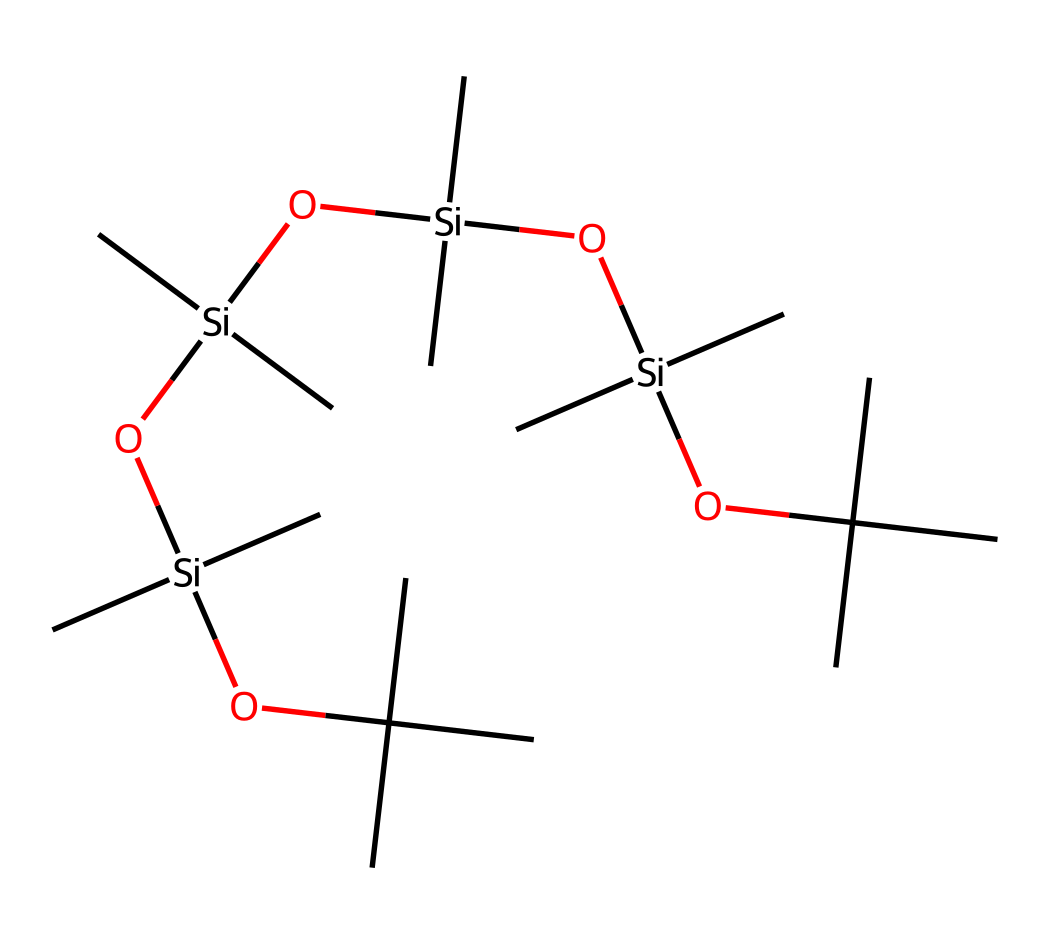How many silicon atoms are present in this chemical structure? The chemical structure contains four silicon atoms, which can be counted directly from the SMILES representation. Each occurrence of “[Si]” represents a silicon atom.
Answer: four What is the primary functional group associated with this compound? The primary functional group in this compound is the alkoxysilane, indicated by the presence of “OC(C)(C)C”. This is characteristic of silicone-based compounds.
Answer: alkoxysilane What is the degree of branching in the siloxane backbone? The siloxane backbone shows a high degree of branching due to the presence of multiple tert-butyl groups (indicated by the repeated “C(C)(C)C”) attached to the silicon atoms.
Answer: high How many total carbon atoms are present? The total number of carbon atoms can be counted from the structure. There are 16 carbon atoms from the two tert-butyl groups (8 from each) and 0 from any other groups.
Answer: sixteen What type of silicone is represented by this structure? This structure represents a type of polysiloxane, which is characterized by alternating silicon and oxygen atoms in the backbone, accompanied by organic side groups to enhance properties like hydrophobicity.
Answer: polysiloxane What property does the presence of branching alkyl groups provide to the compound? The presence of branching alkyl groups enhances the hydrophobic properties of the compound, making it effective as a waterproofing agent in electronics by repelling water.
Answer: hydrophobicity 